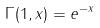<formula> <loc_0><loc_0><loc_500><loc_500>\Gamma ( 1 , x ) = e ^ { - x }</formula> 